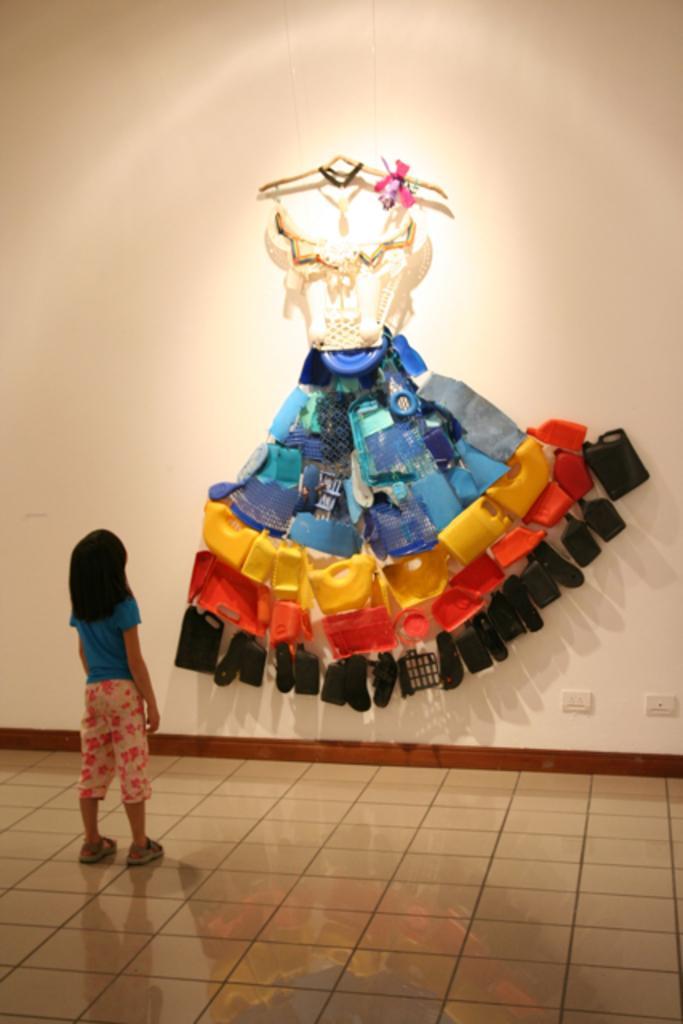Please provide a concise description of this image. On the left side, there is a girl in blue color T-shirt, standing on the floor. In the background, there are yellow, orange and black color bottles, blue, white and other objects arranged as a dress on a white color wall. 